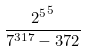<formula> <loc_0><loc_0><loc_500><loc_500>\frac { { 2 ^ { 5 } } ^ { 5 } } { 7 ^ { 3 1 7 } - 3 7 2 }</formula> 